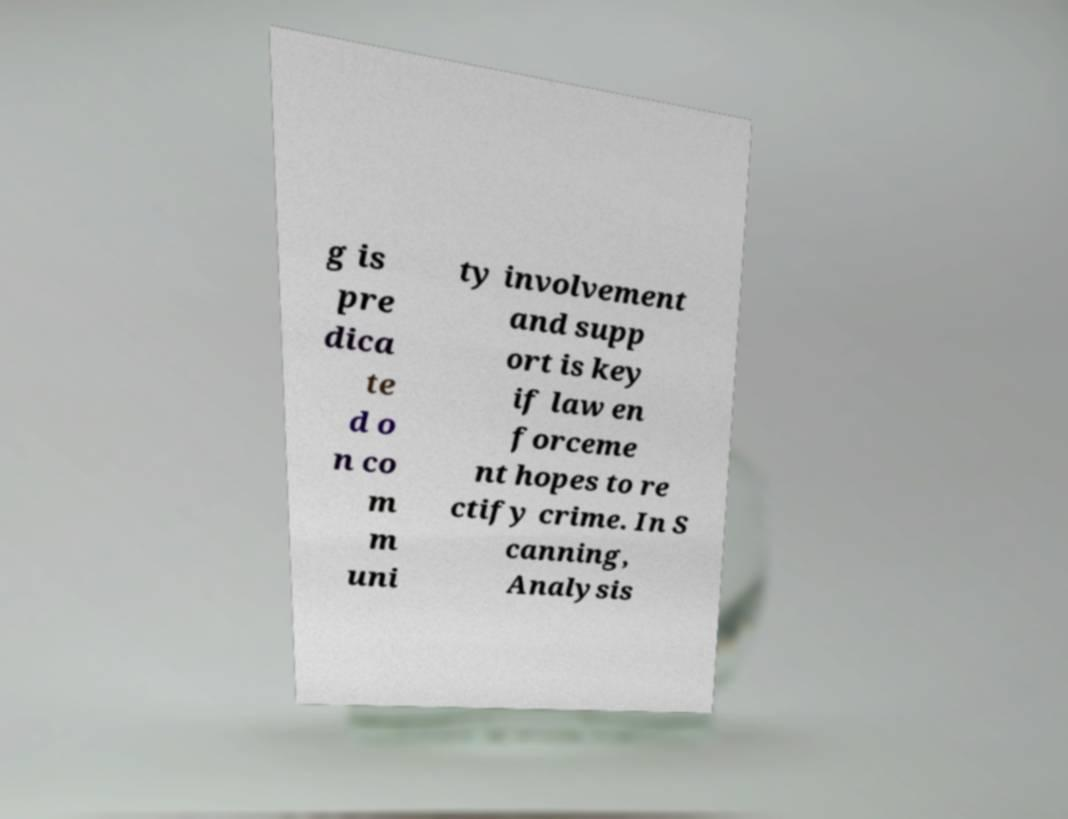What messages or text are displayed in this image? I need them in a readable, typed format. g is pre dica te d o n co m m uni ty involvement and supp ort is key if law en forceme nt hopes to re ctify crime. In S canning, Analysis 